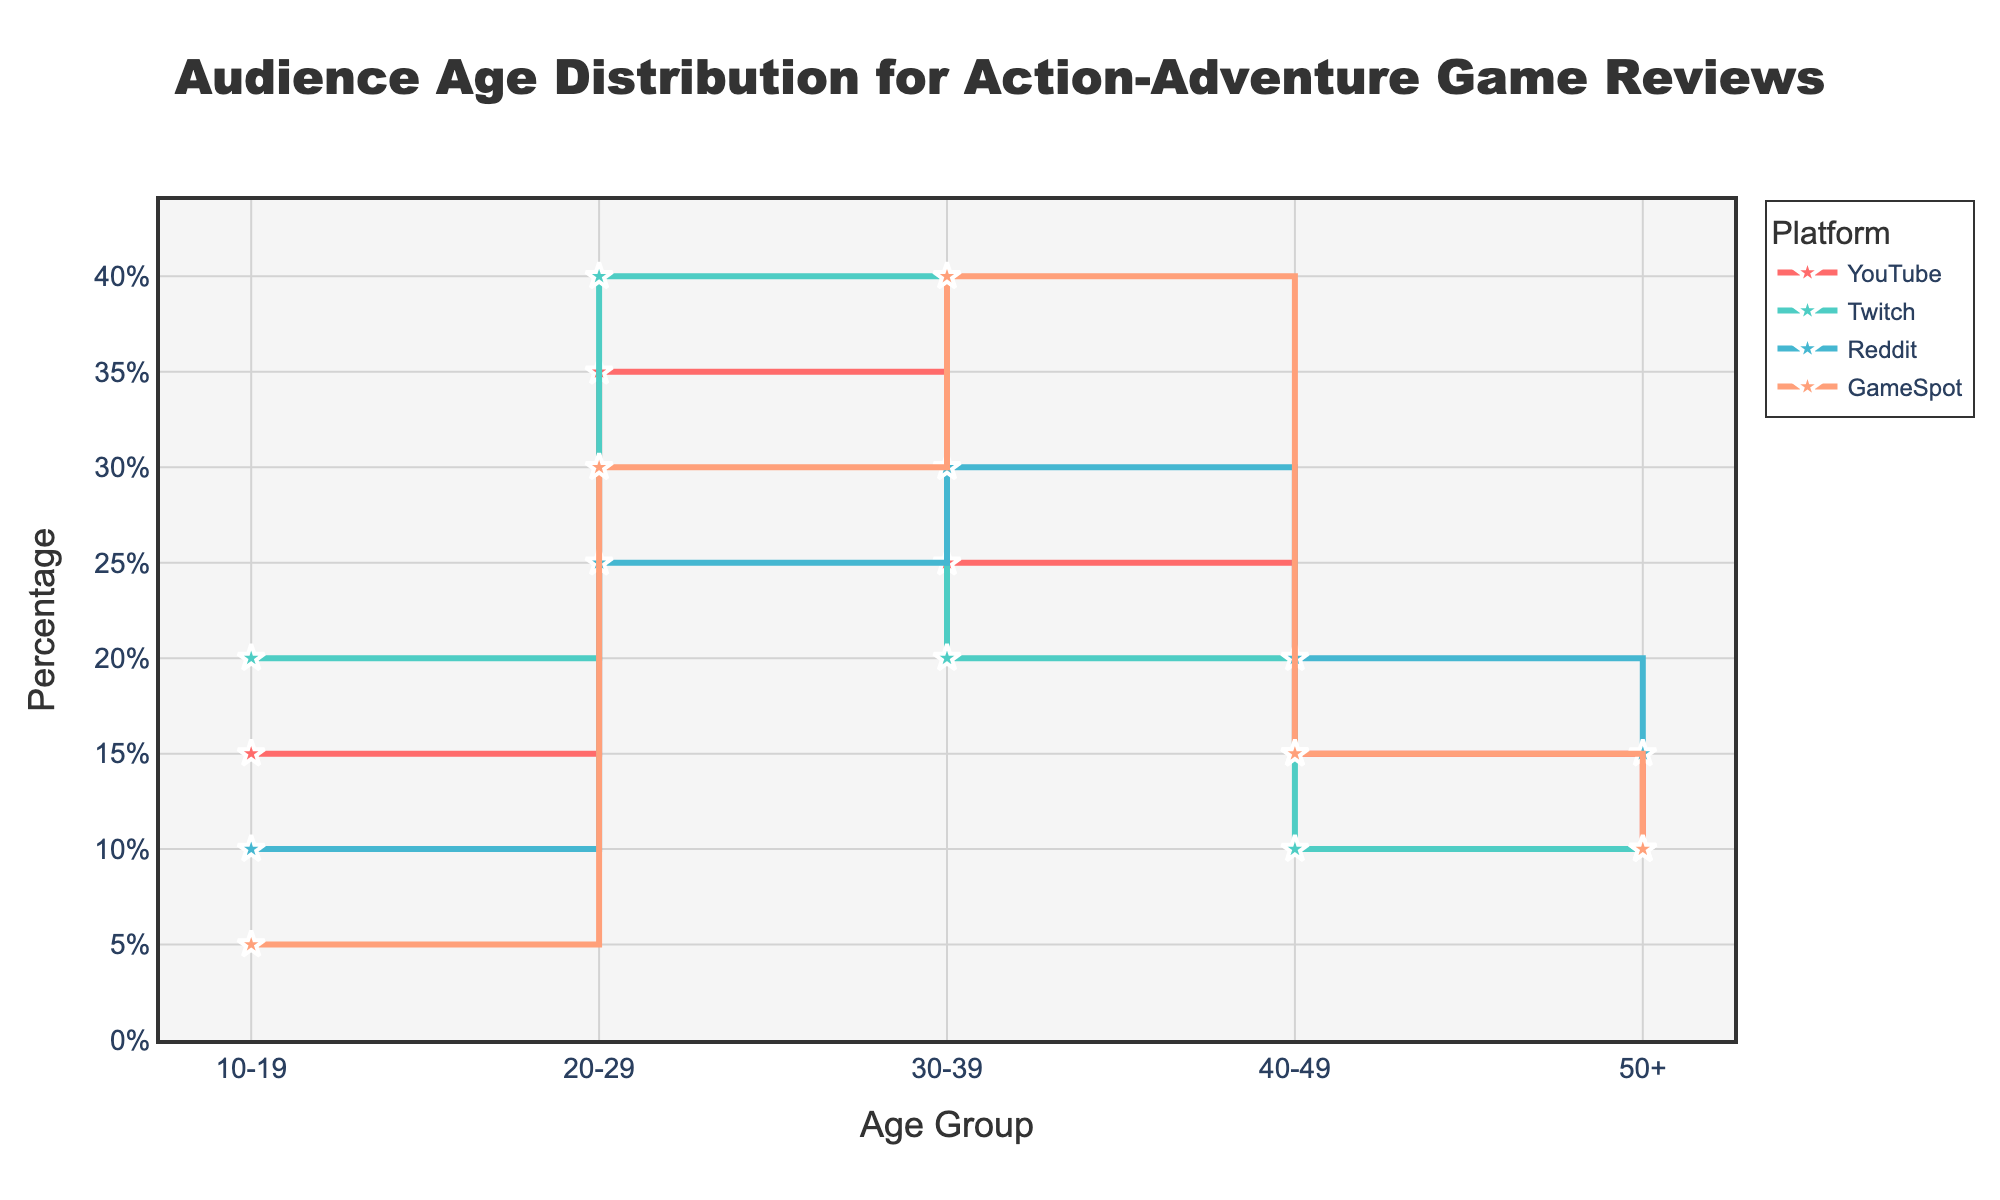Which platform has the highest percentage of viewers in the 20-29 age group? To determine the platform with the highest percentage for the 20-29 age group, look at the points plotted above this age group for all platforms. YouTube has 35%, Twitch has 40%, Reddit has 25%, and GameSpot has 30%. Twitch has the highest percentage.
Answer: Twitch Which age group has the lowest percentage of GameSpot viewers? To find this, look at the percentages across all age groups for GameSpot. For 10-19, it's 5%; for 20-29, it's 30%; for 30-39, it's 40%; for 40-49, it's 15%; for 50+, it's 10%. The lowest percentage is 5% for the 10-19 age group.
Answer: 10-19 What is the combined percentage of Reddit viewers for the 30-39 and 40-49 age groups? To calculate the combined percentage, sum the values for the 30-39 and 40-49 age groups on Reddit. The values are 30% and 20%, respectively. Adding these gives 30 + 20 = 50%.
Answer: 50% Which platform has the most balanced audience distribution across all age groups? To determine this, observe how evenly the percentages are spread across all age groups for each platform. GameSpot seems to have the most even distribution with values of 5%, 30%, 40%, 15%, and 10%.
Answer: GameSpot How does the percentage of YouTube viewers in the 50+ age group compare to those in the 30-39 age group? Compare the percentage values directly. For the 50+ age group, YouTube has 10%, and for the 30-39 age group, it has 25%. The 30-39 age group has a higher percentage.
Answer: The 30-39 age group has a higher percentage Which age group sees the smallest difference in viewership percentages between Twitch and Reddit? Calculate the differences in percentages between Twitch and Reddit for each age group and find the smallest difference. For 10-19: 20% - 10% = 10%, for 20-29: 40% - 25% = 15%, for 30-39: 20% - 30% = 10%, for 40-49: 10% - 20% = 10%, and for 50+: 10% - 15% = 5%. The smallest difference is 5% for the 50+ age group.
Answer: 50+ What is the average percentage of viewers in the 20-29 age group across all platforms? To find the average, sum the percentages for the 20-29 age group across all platforms and divide by the number of platforms. (35 + 40 + 25 + 30) / 4 = 130 / 4 = 32.5%.
Answer: 32.5% How does the viewership for the 30-39 age group on Reddit compare to YouTube? Compare the percentage values directly. Reddit has 30%, while YouTube has 25%. Reddit has a higher percentage.
Answer: Reddit has a higher percentage Which platform sees a decline in viewership percentages consistently as the age groups increase? Look for a platform where the percentages decrease consistently from younger to older age groups. YouTube declines from 15% (10-19), 35% (20-29), 25% (30-39), 15% (40-49), and 10% (50+).
Answer: YouTube 